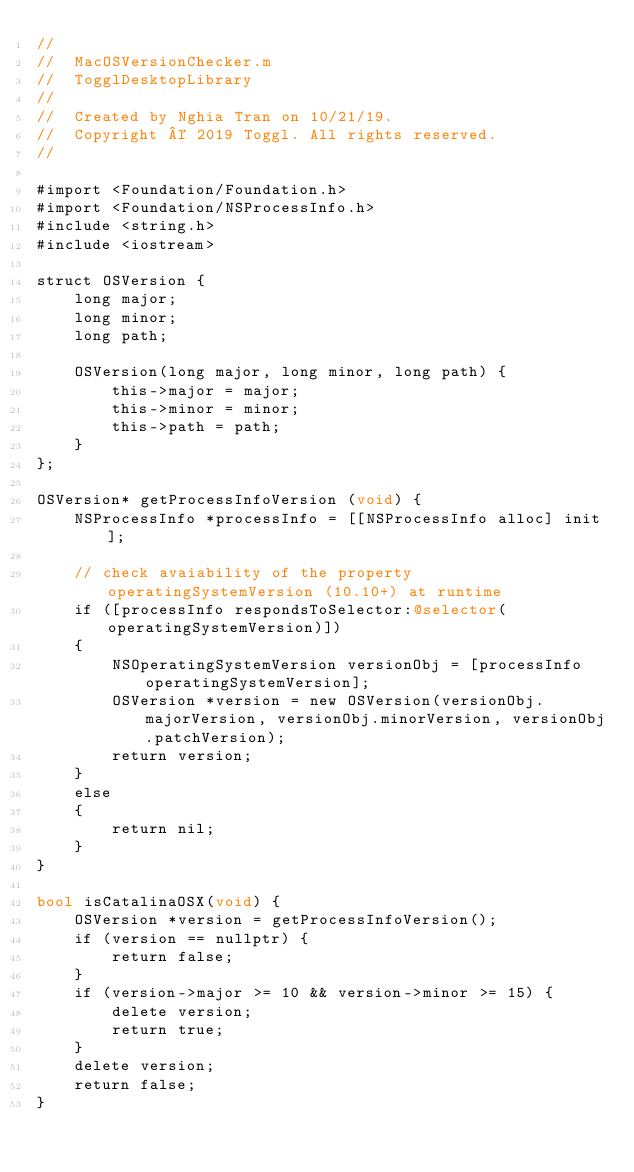<code> <loc_0><loc_0><loc_500><loc_500><_ObjectiveC_>//
//  MacOSVersionChecker.m
//  TogglDesktopLibrary
//
//  Created by Nghia Tran on 10/21/19.
//  Copyright © 2019 Toggl. All rights reserved.
//

#import <Foundation/Foundation.h>
#import <Foundation/NSProcessInfo.h>
#include <string.h>
#include <iostream>

struct OSVersion {
    long major;
    long minor;
    long path;

    OSVersion(long major, long minor, long path) {
        this->major = major;
        this->minor = minor;
        this->path = path;
    }
};

OSVersion* getProcessInfoVersion (void) {
    NSProcessInfo *processInfo = [[NSProcessInfo alloc] init];

    // check avaiability of the property operatingSystemVersion (10.10+) at runtime
    if ([processInfo respondsToSelector:@selector(operatingSystemVersion)])
    {
        NSOperatingSystemVersion versionObj = [processInfo operatingSystemVersion];
        OSVersion *version = new OSVersion(versionObj.majorVersion, versionObj.minorVersion, versionObj.patchVersion);
        return version;
    }
    else
    {
        return nil;
    }
}

bool isCatalinaOSX(void) {
    OSVersion *version = getProcessInfoVersion();
    if (version == nullptr) {
        return false;
    }
    if (version->major >= 10 && version->minor >= 15) {
        delete version;
        return true;
    }
    delete version;
    return false;
}
</code> 